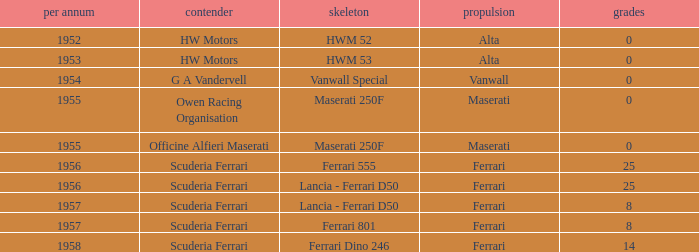What company made the chassis when there were 8 points? Lancia - Ferrari D50, Ferrari 801. 